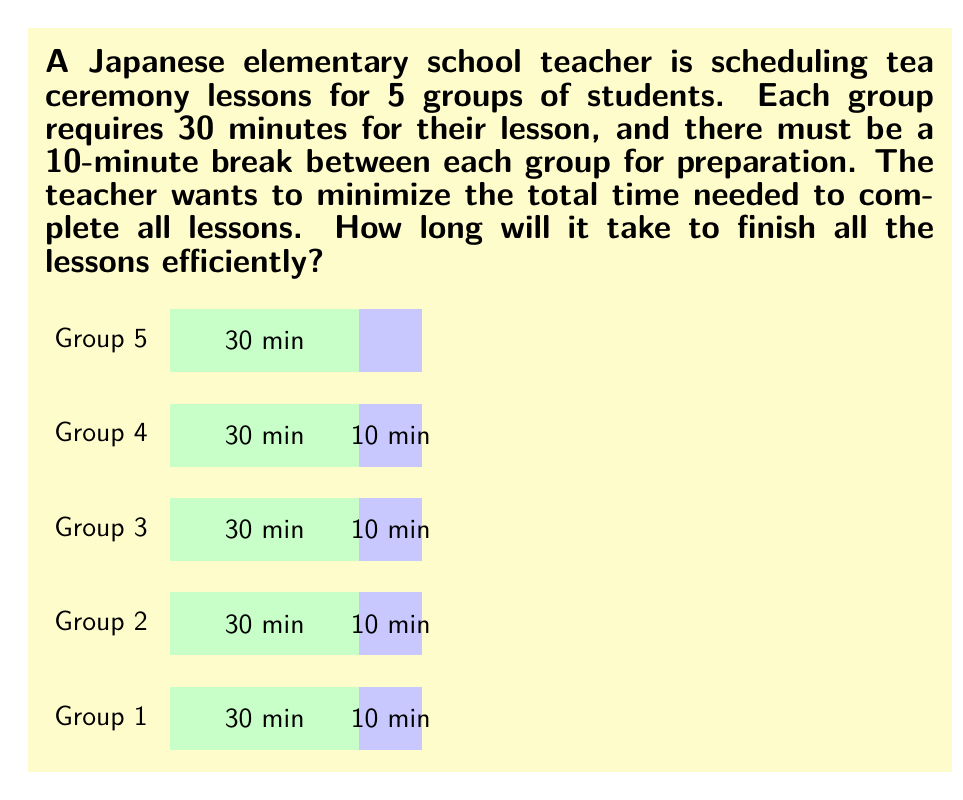Can you answer this question? Let's approach this step-by-step:

1) First, we need to calculate the time for each group's lesson:
   - Each lesson takes 30 minutes

2) Next, we need to account for the breaks between lessons:
   - There are 4 breaks (one less than the number of groups)
   - Each break is 10 minutes

3) Now, let's set up our equation:
   $$ \text{Total Time} = (\text{Number of Groups} \times \text{Lesson Time}) + (\text{Number of Breaks} \times \text{Break Time}) $$

4) Plugging in our values:
   $$ \text{Total Time} = (5 \times 30) + (4 \times 10) $$

5) Simplify:
   $$ \text{Total Time} = 150 + 40 = 190 \text{ minutes} $$

6) Convert to hours and minutes:
   $$ 190 \text{ minutes} = 3 \text{ hours and } 10 \text{ minutes} $$

This scheduling is efficient because it minimizes idle time between lessons while allowing for necessary preparation.
Answer: 3 hours and 10 minutes 